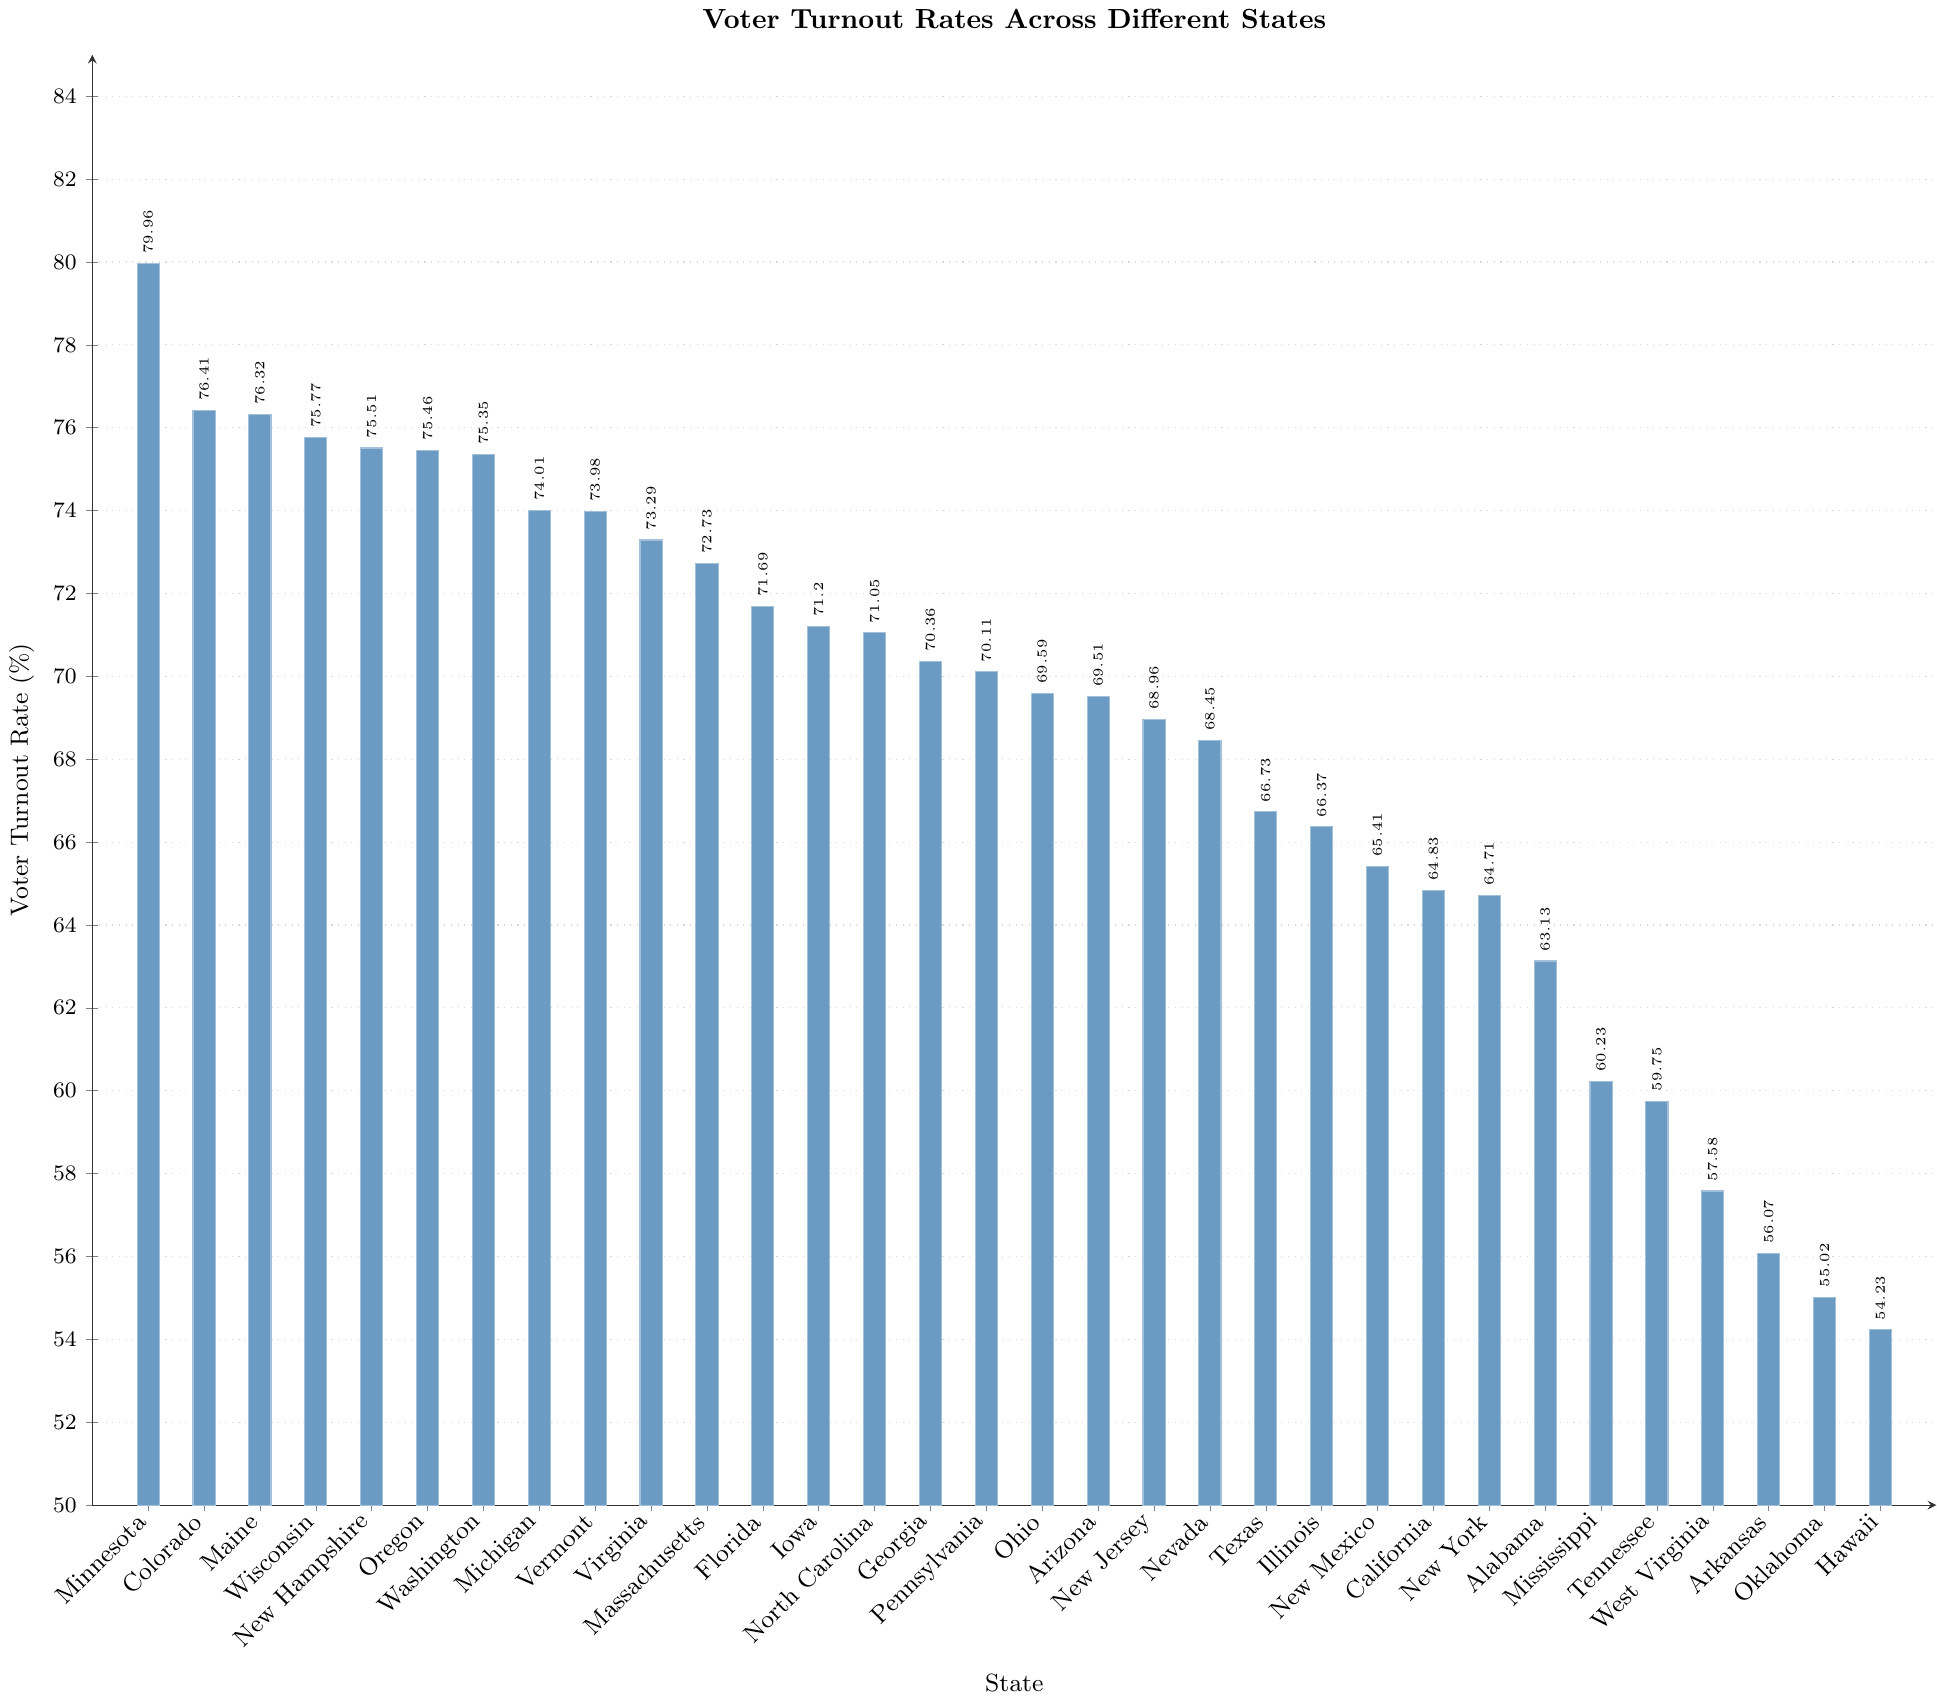What's the voter turnout rate for Minnesota? The plot shows the voter turnout rates for each state as bars, with labels indicating the exact rates. Locate the bar labeled "Minnesota" to find the turnout rate.
Answer: 79.96% Which state has the lowest voter turnout rate? Review the heights of all the bars and identify the shortest one, which represents the lowest voter turnout rate. The associated label indicates the state.
Answer: Hawaii How much higher is the voter turnout rate in Colorado compared to Illinois? Find the heights of the bars for both Colorado and Illinois. Subtract the turnout rate for Illinois from that of Colorado.
Answer: 76.41 - 66.37 = 10.04% What’s the average voter turnout rate among the top 5 states? Identify the top 5 states by voter turnout rate: Minnesota, Colorado, Maine, Wisconsin, and New Hampshire. Add their turnout rates and divide by 5 to get the average. (79.96 + 76.41 + 76.32 + 75.77 + 75.51) / 5 = 76.394
Answer: 76.394% What is the median voter turnout rate in the figure? Arrange the voter turnout rates in descending order, and find the middle value. With 32 states, the median value is the average of the 16th and 17th values: Pennsylvania and Ohio. (70.11 + 69.59) / 2 = 69.85
Answer: 69.85% Which states have voter turnout rates greater than 70% but less than 75%? Examine the bars and identify those with heights representing values between 70% and 75%.
Answer: Michigan, Vermont, Virginia, Massachusetts, Florida, Iowa, North Carolina, Georgia, Pennsylvania, Ohio, Arizona Is the voter turnout rate in Texas higher or lower than the average rate of all states in the figure? Calculate the average turnout rate of all 32 states and compare it to the turnout rate of Texas. Sum all turnout rates and divide by 32. Average = (sum of all rates) / 32 = 68.31%. Texas has 66.73%.
Answer: Lower How many states have a voter turnout rate below the national average turnout rate of 66.8%? Compare each state's voter turnout rate to 66.8% and count how many are below this threshold. 66.73 (Texas) and below.
Answer: 12 Which states have a higher turnout rate than New York but lower than Virginia? Identify the states with voter turnout rates between New York’s and Virginia. New York: 64.71%, Virginia: 73.29%.
Answer: Massachusetts, Florida, Iowa, North Carolina, Georgia, Pennsylvania, Ohio, Arizona, New Jersey, Nevada, Texas, Illinois, New Mexico, California 